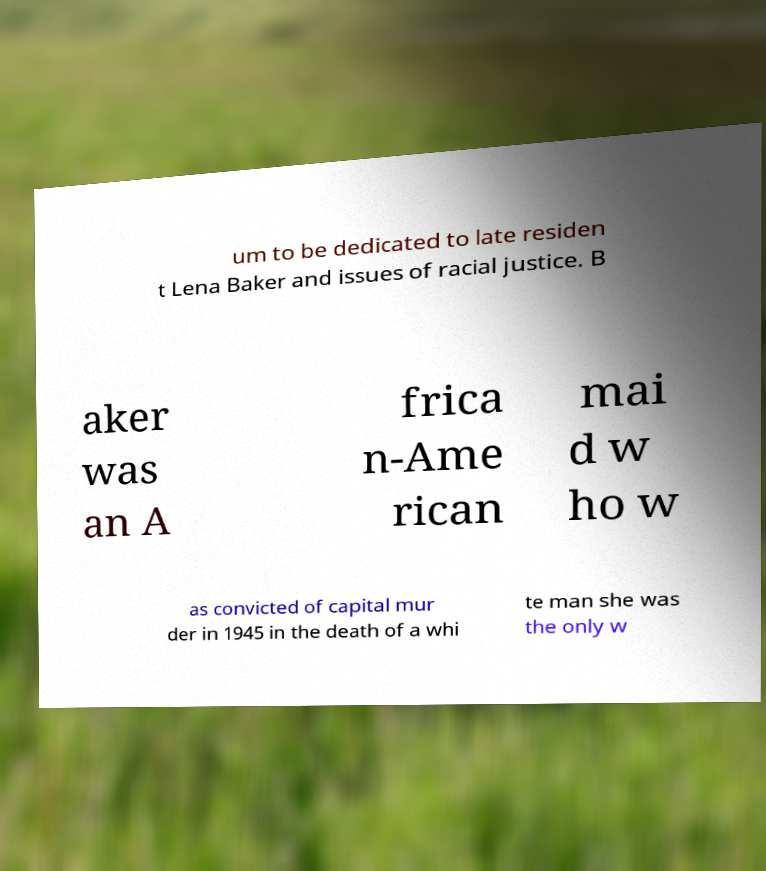Can you accurately transcribe the text from the provided image for me? um to be dedicated to late residen t Lena Baker and issues of racial justice. B aker was an A frica n-Ame rican mai d w ho w as convicted of capital mur der in 1945 in the death of a whi te man she was the only w 